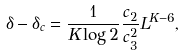Convert formula to latex. <formula><loc_0><loc_0><loc_500><loc_500>\delta - \delta _ { c } = \frac { 1 } { K \log 2 } \frac { c _ { 2 } } { c _ { 3 } ^ { 2 } } L ^ { K - 6 } ,</formula> 